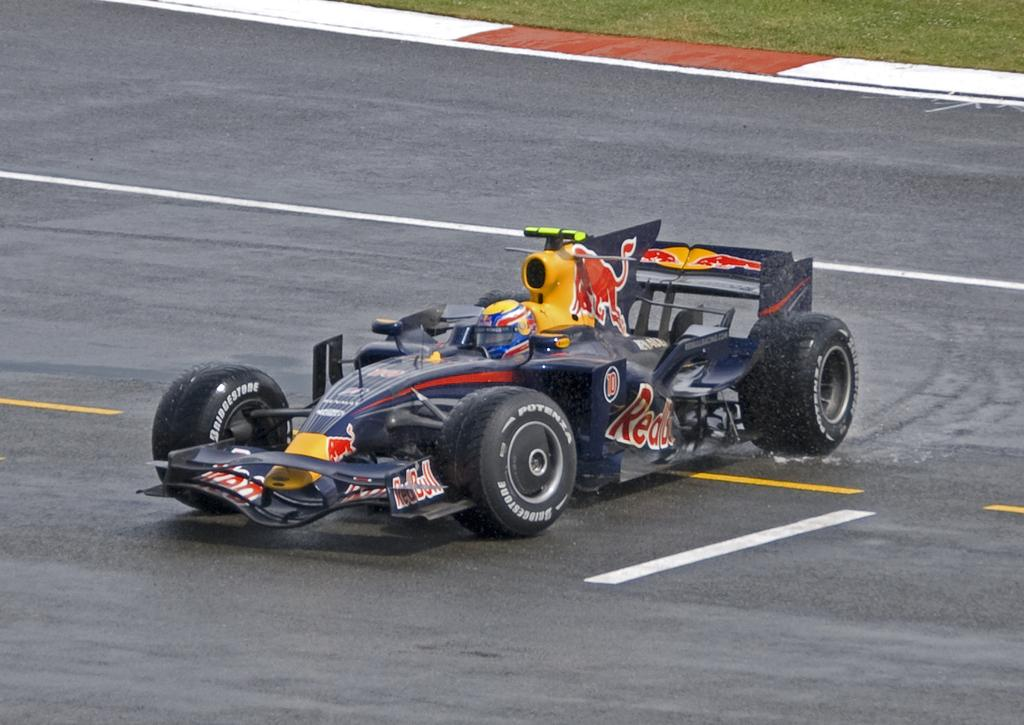What is the main subject of the image? The main subject of the image is a go-kart. Where is the go-kart located in the image? The go-kart is on the road in the image. What safety gear is the person wearing in the image? The person is wearing a helmet in the image. What can be seen on the road in the image? There are white and yellow color lines on the road in the image. What is the color of the go-kart? The go-kart is black in color. What type of animal can be seen talking in the image? There is no animal present in the image, and no one is talking. 